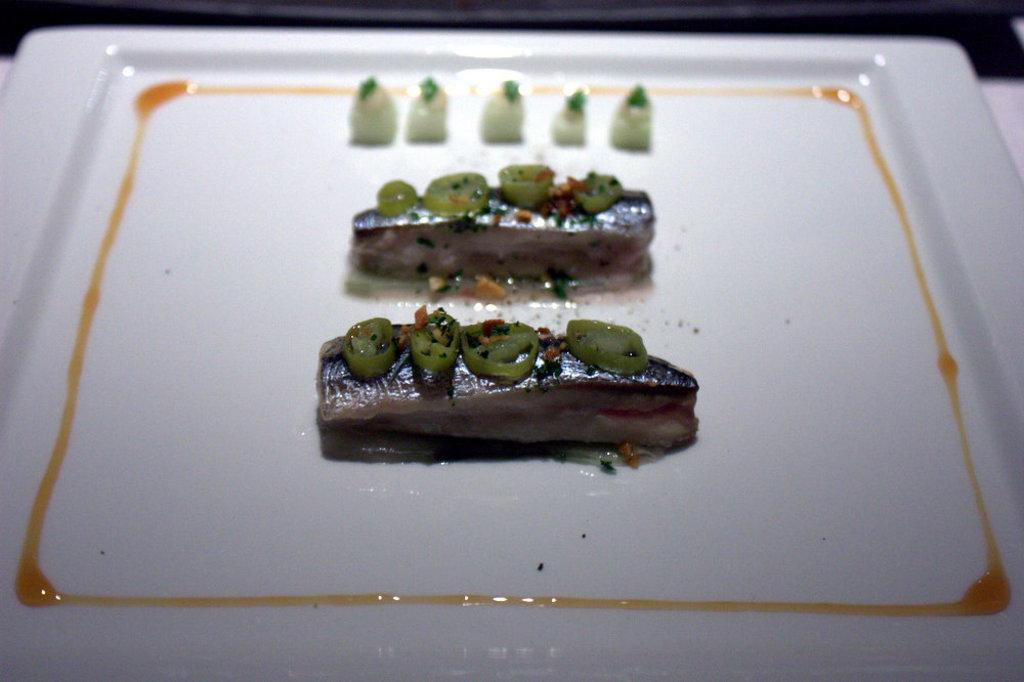What is the color of the plate in the image? The plate in the image is white. What is on the plate? The plate contains food. Can you describe the colors of the food on the plate? The food has white, green, and brown colors. How many legs does the food on the plate have? The food on the plate does not have legs, as it is not a living creature. 